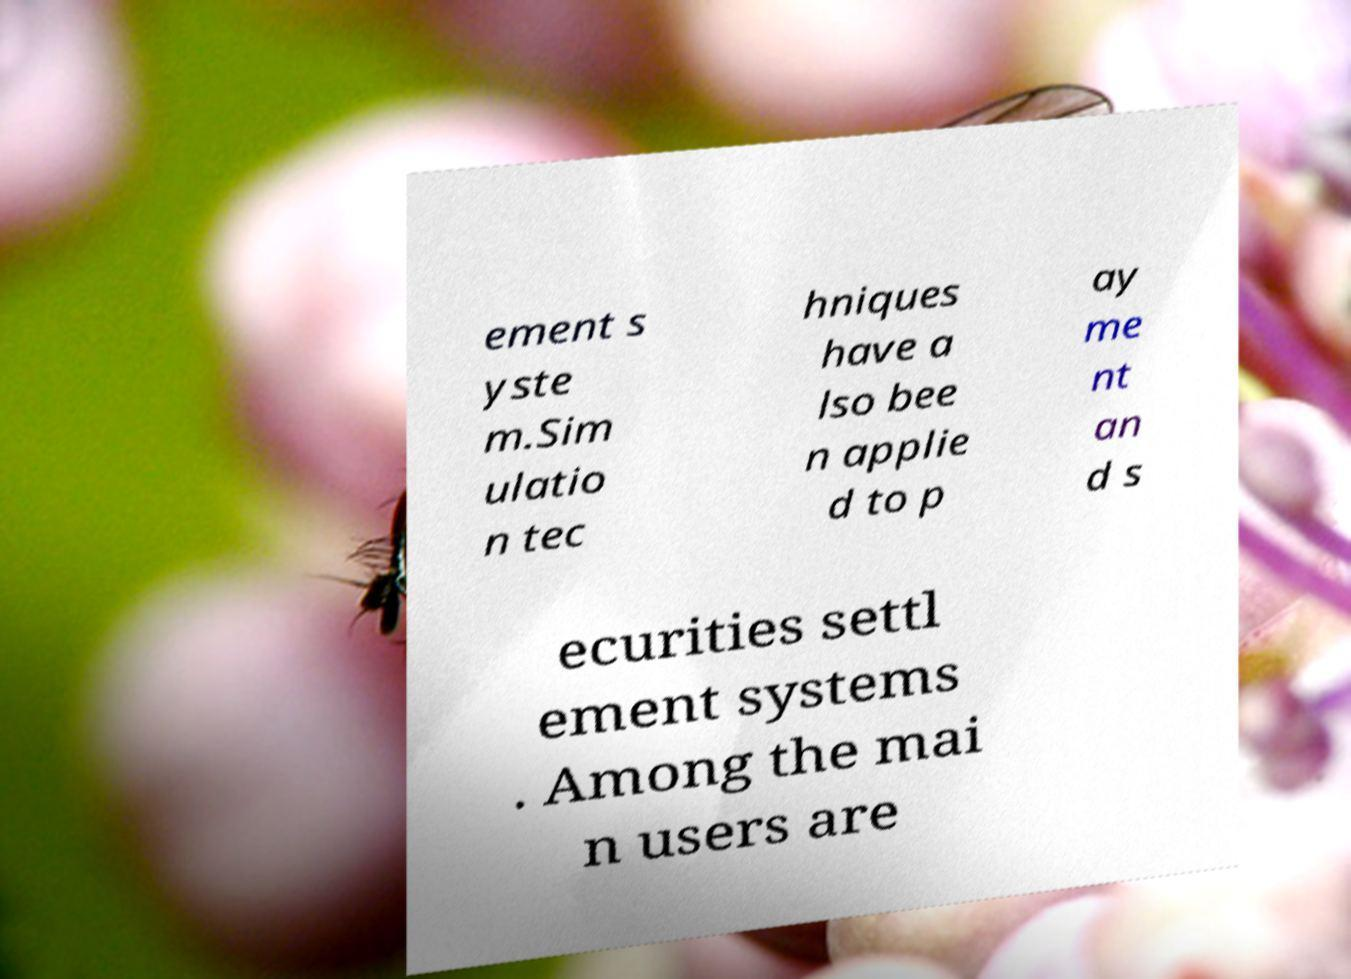Please read and relay the text visible in this image. What does it say? ement s yste m.Sim ulatio n tec hniques have a lso bee n applie d to p ay me nt an d s ecurities settl ement systems . Among the mai n users are 